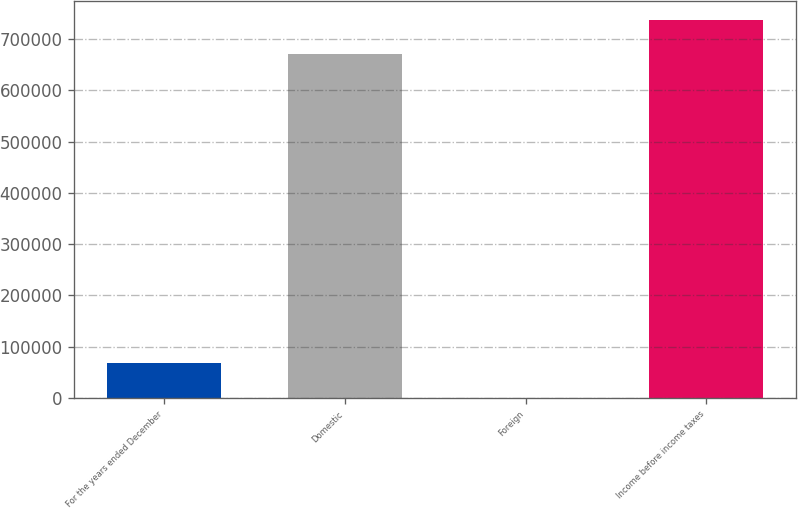Convert chart to OTSL. <chart><loc_0><loc_0><loc_500><loc_500><bar_chart><fcel>For the years ended December<fcel>Domestic<fcel>Foreign<fcel>Income before income taxes<nl><fcel>67453.3<fcel>670753<fcel>378<fcel>737828<nl></chart> 